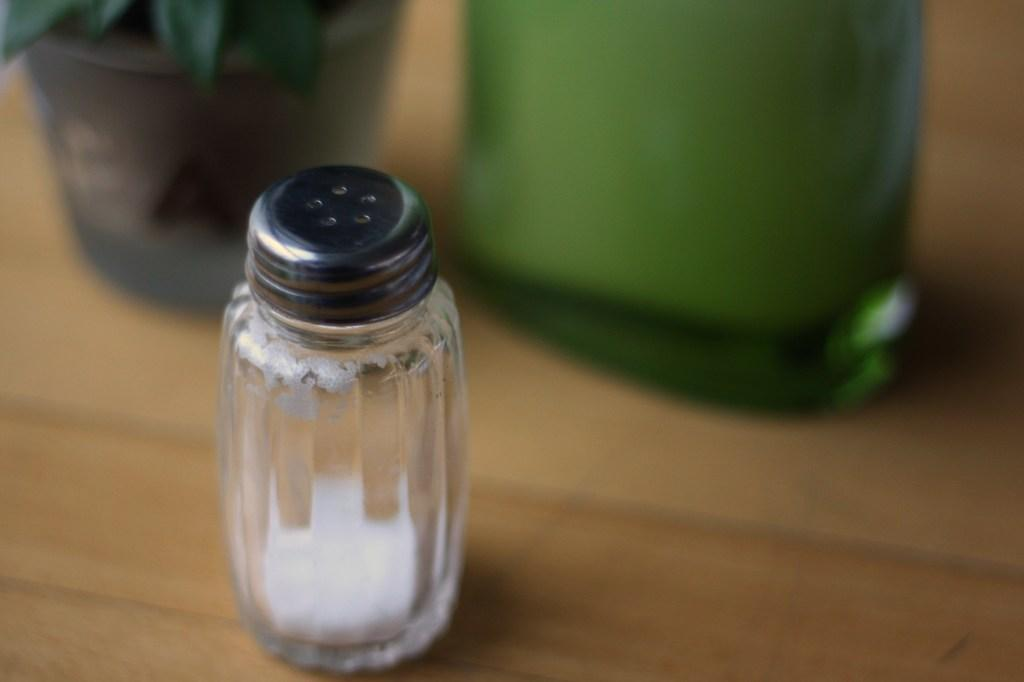What can be seen in the image? There are objects in the image. Where is the house plant located in the image? The house plant is at the top left side of the image. What type of surface is visible in the image? There is a wooden surface in the image. How would you describe the background of the image? The background of the image is blurred. What type of feeling does the existence of the house plant evoke in the image? The image does not convey feelings or emotions, so it is not possible to determine the feeling evoked by the existence of the house plant. 